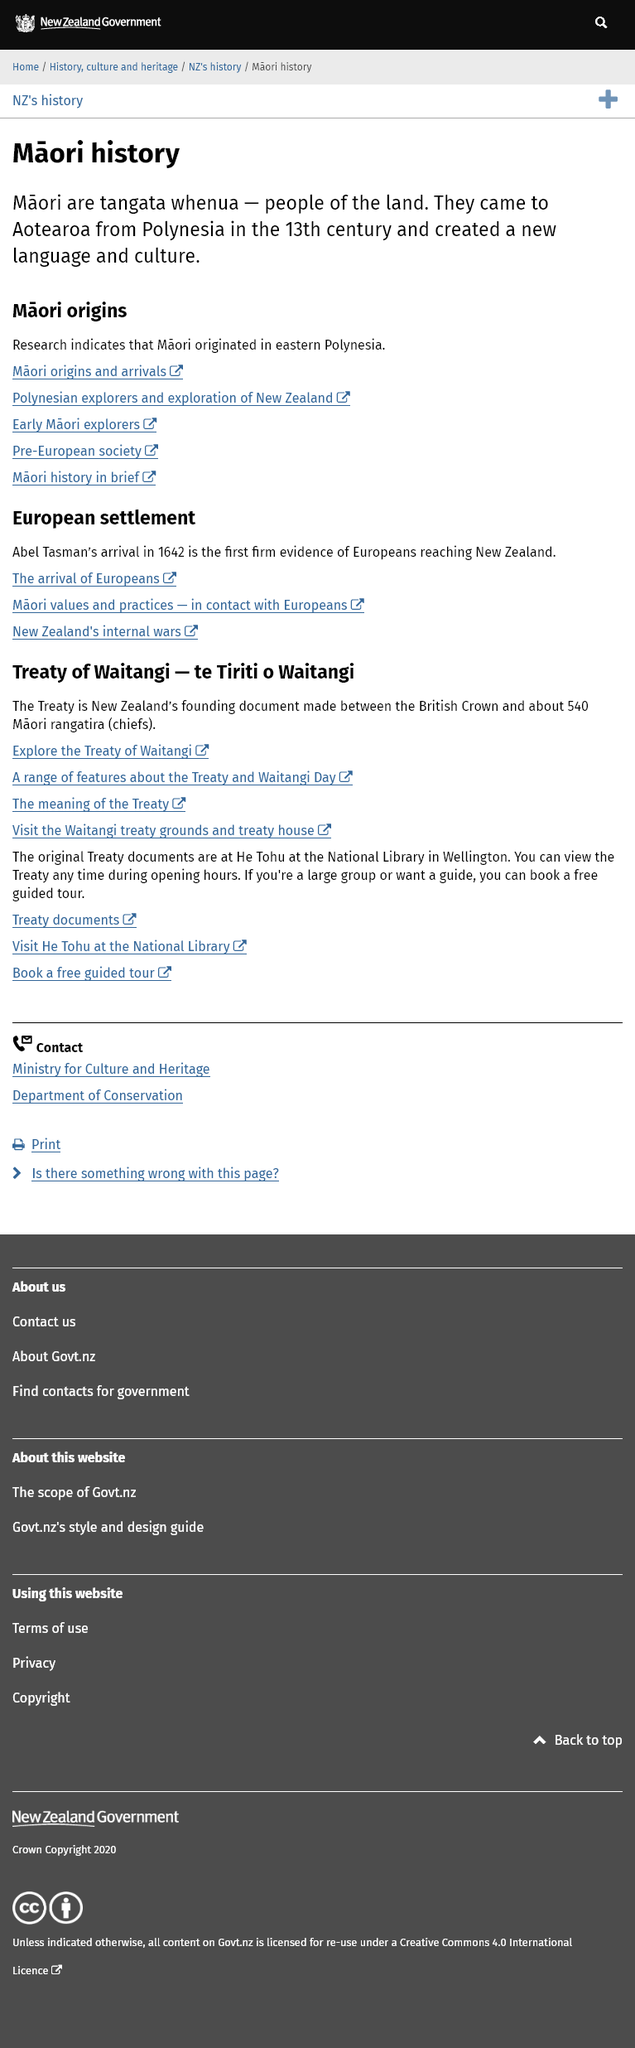Outline some significant characteristics in this image. The Maori people arrived in Aotearoa, also known as New Zealand, in the 13th century, originating from Polynesia. The first firm evidence of Europeans reaching New Zealand occurred in 1642. The term "tangata whenua" refers to the Maori people as "people of the land. 